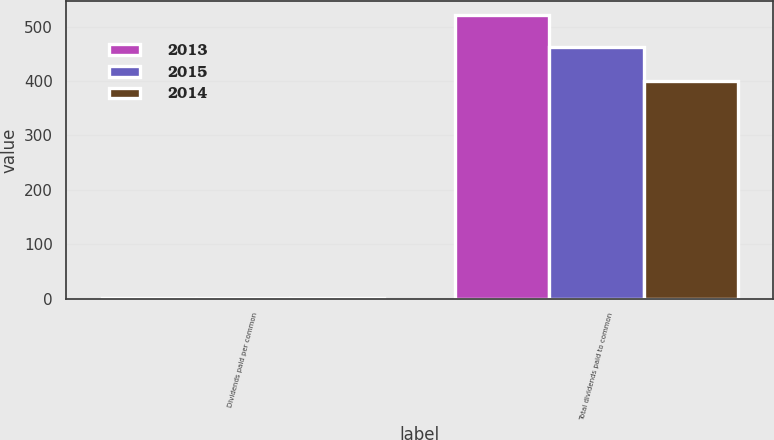Convert chart. <chart><loc_0><loc_0><loc_500><loc_500><stacked_bar_chart><ecel><fcel>Dividends paid per common<fcel>Total dividends paid to common<nl><fcel>2013<fcel>1.34<fcel>521<nl><fcel>2015<fcel>1.22<fcel>462<nl><fcel>2014<fcel>1.06<fcel>401<nl></chart> 